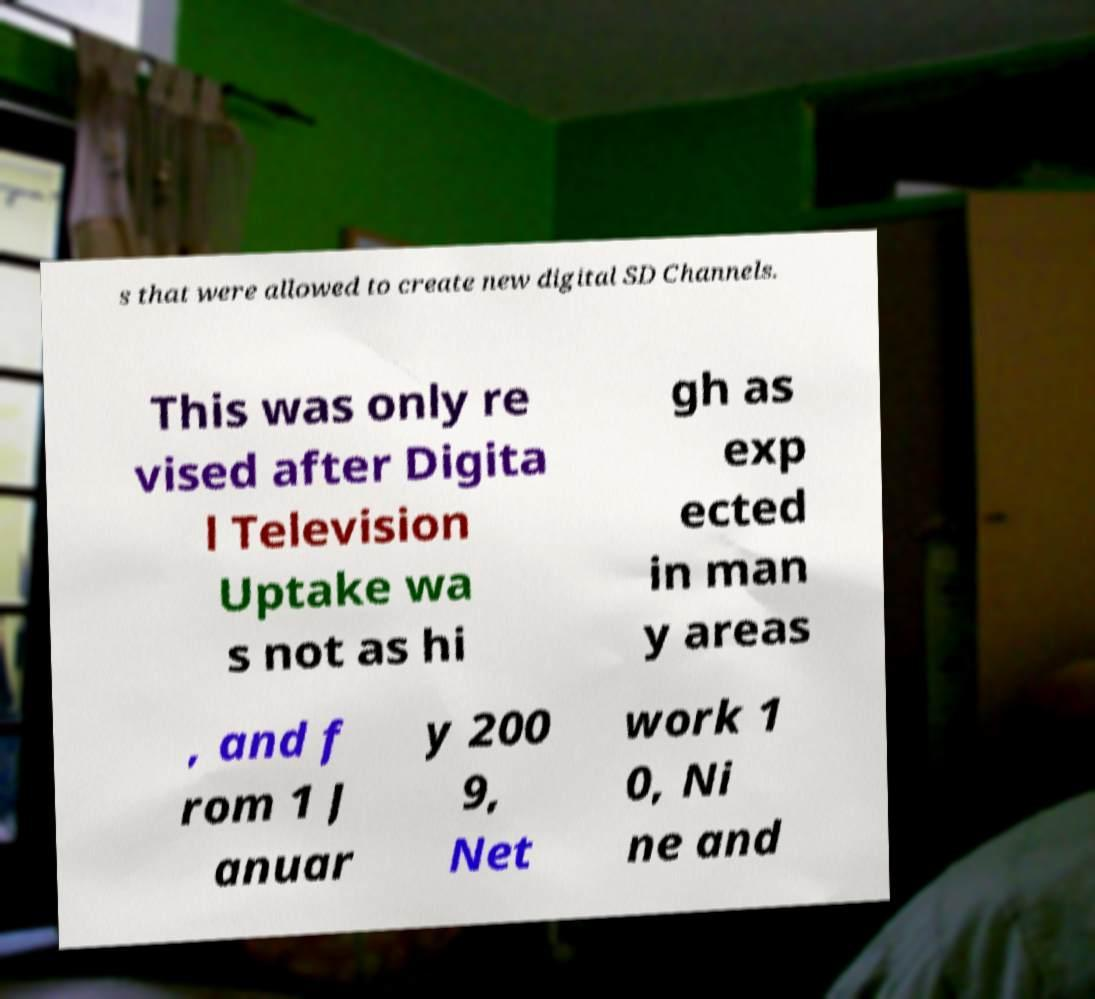Please identify and transcribe the text found in this image. s that were allowed to create new digital SD Channels. This was only re vised after Digita l Television Uptake wa s not as hi gh as exp ected in man y areas , and f rom 1 J anuar y 200 9, Net work 1 0, Ni ne and 